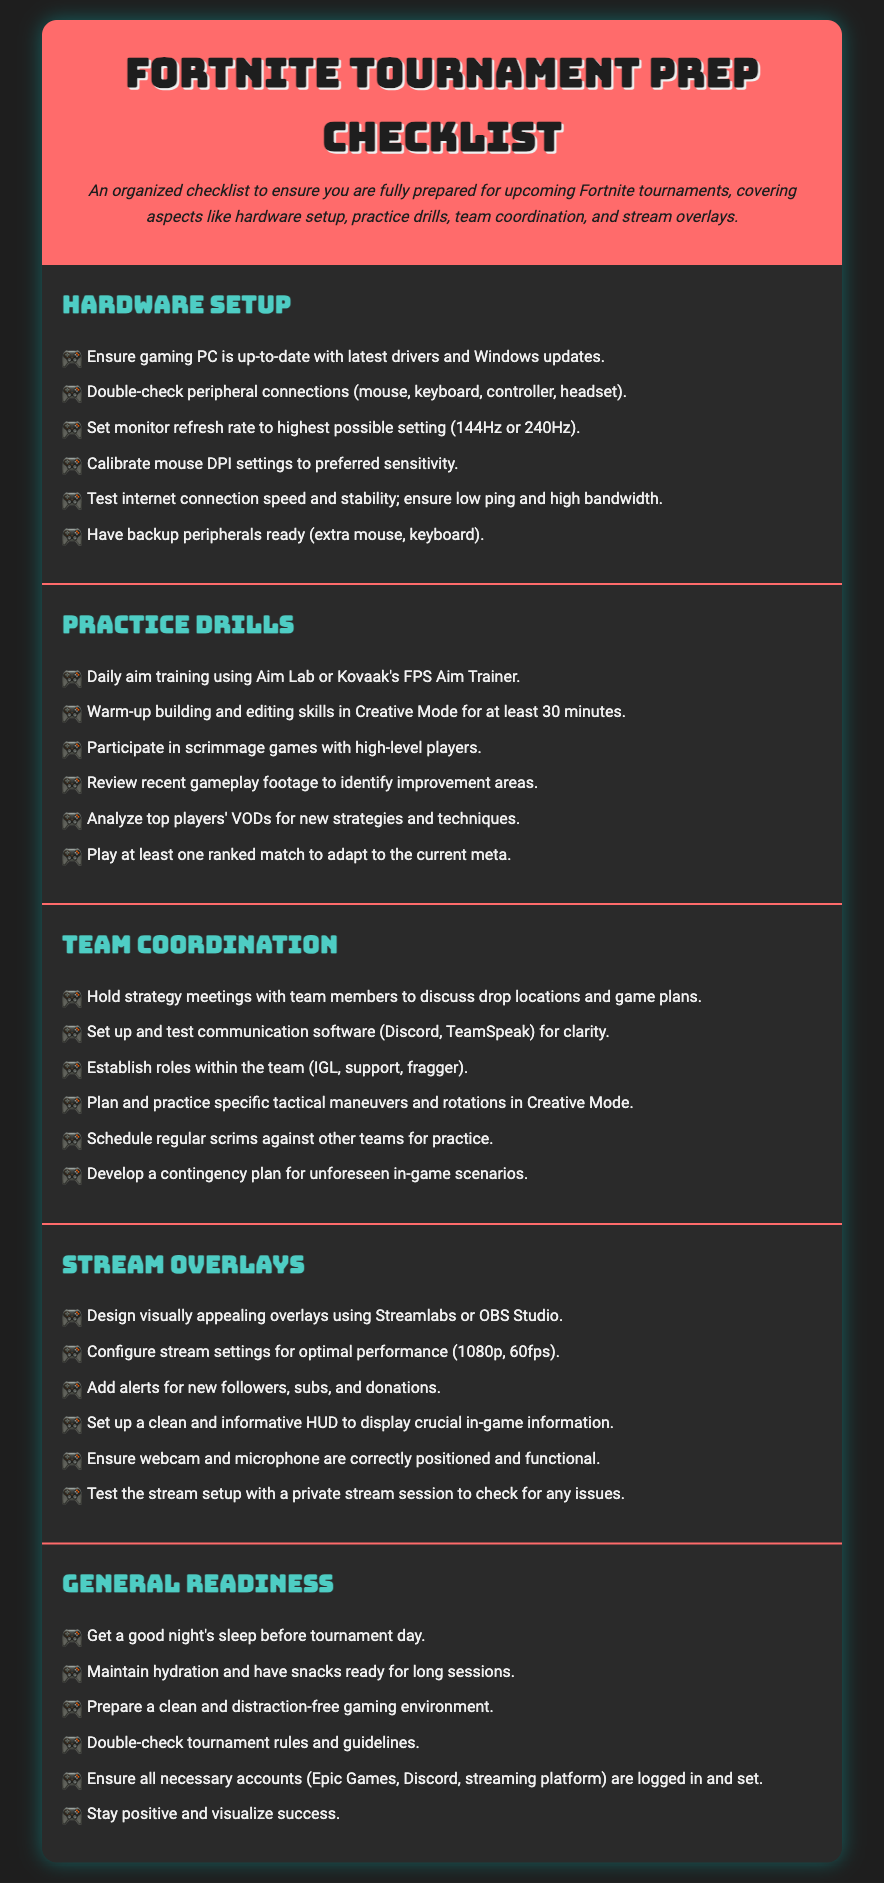What is the title of the document? The title is prominently displayed at the top of the document and identifies the main subject matter.
Answer: Fortnite Tournament Prep Checklist How many sections are in the document? The document contains multiple sections, which are clearly delineated with headings.
Answer: 5 What is the first item listed under Hardware Setup? The first item in the Hardware Setup section indicates an important preliminary step for gamers to take.
Answer: Ensure gaming PC is up-to-date with latest drivers and Windows updates What type of training is suggested for Daily aim training? This question focuses on the type of aim training recommended in the Practice Drills section.
Answer: Aim Lab or Kovaak's FPS Aim Trainer What is a suggested practice activity in the Team Coordination section? This request looks for a specific practice strategy outlined in the Team Coordination section.
Answer: Hold strategy meetings with team members What is emphasized in the General Readiness section? This inquiry seeks an important aspect highlighted to promote optimal performance on tournament day.
Answer: Good night's sleep How should stream settings be configured according to the document? The document suggests specific performance metrics in the Stream Overlays section.
Answer: 1080p, 60fps What is the last item listed in the Stream Overlays section? This question focuses on the concluding suggestion for stream preparation found within that section.
Answer: Test the stream setup with a private stream session to check for any issues What role does the IGL have within a team? This question asks for clarification on a specific team role mentioned in the Team Coordination section.
Answer: In-Game Leader 